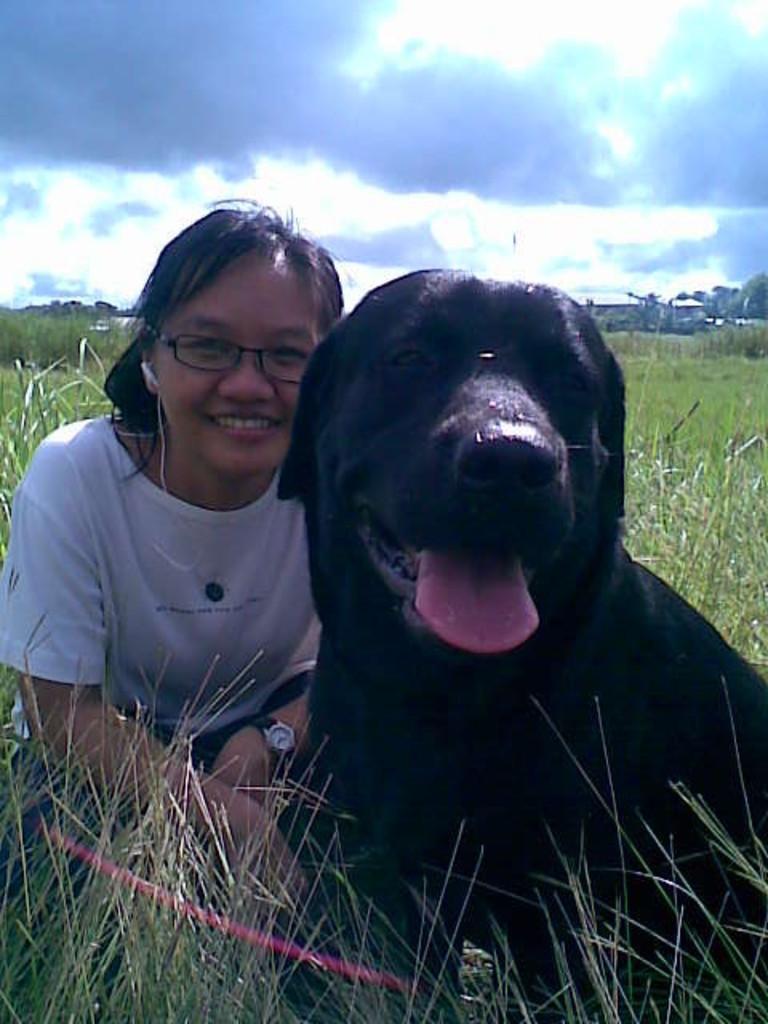How would you summarize this image in a sentence or two? In this picture there is a woman and a dog sitting in the grass. Sky is cloudy in the background. 